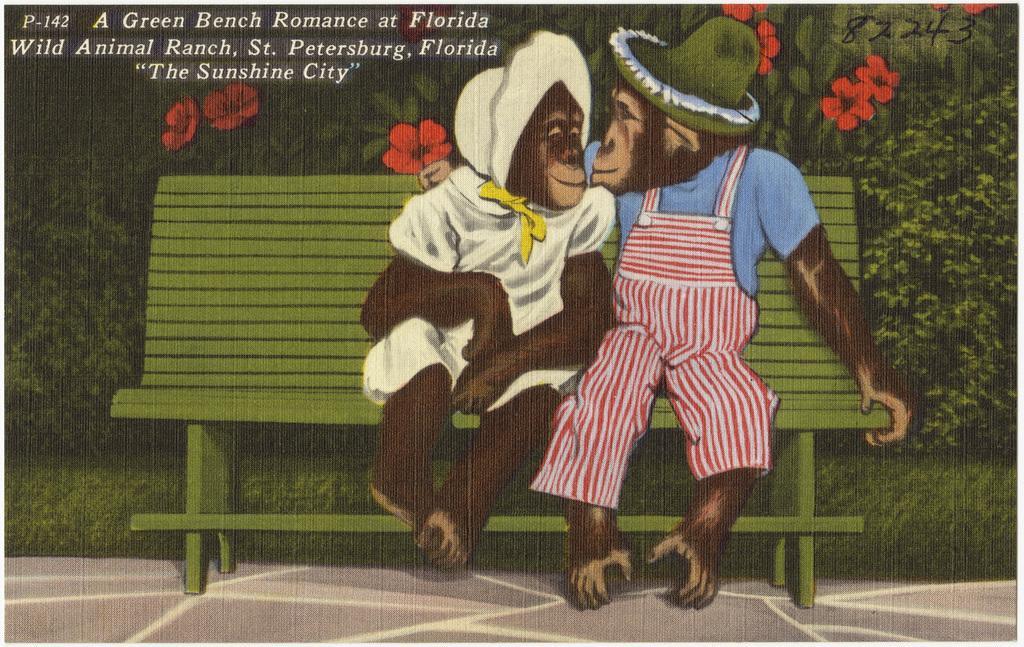Could you give a brief overview of what you see in this image? It is a poster. In this poster, we can see monkeys are sitting on the bench. At the bottom, there is a walkway. Background we can see grass, plants, flowers and some text. On the right side top corner, we can see numbers. 